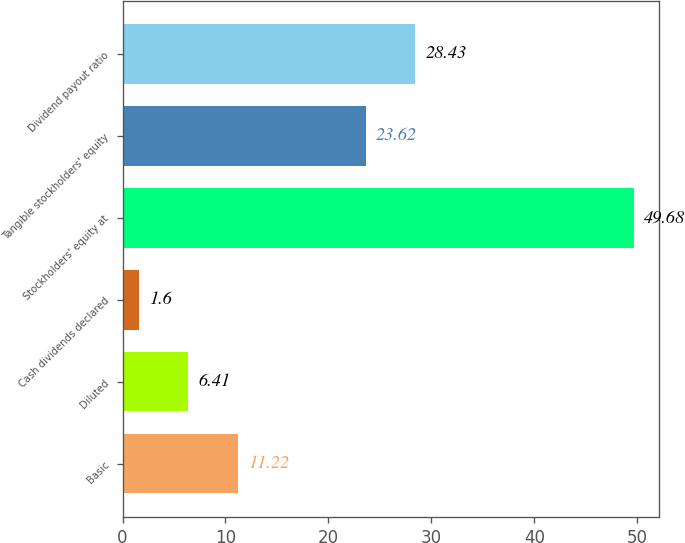Convert chart to OTSL. <chart><loc_0><loc_0><loc_500><loc_500><bar_chart><fcel>Basic<fcel>Diluted<fcel>Cash dividends declared<fcel>Stockholders' equity at<fcel>Tangible stockholders' equity<fcel>Dividend payout ratio<nl><fcel>11.22<fcel>6.41<fcel>1.6<fcel>49.68<fcel>23.62<fcel>28.43<nl></chart> 